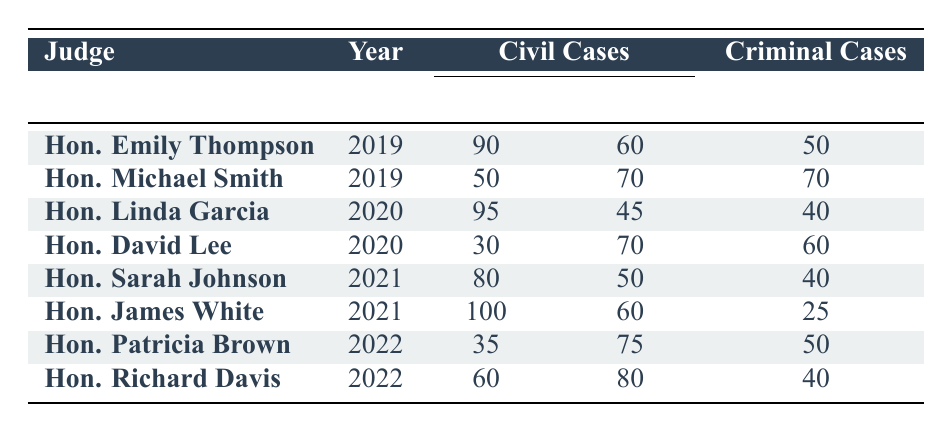What was the total number of criminal cases handled by Hon. Emily Thompson in 2019? Hon. Emily Thompson had a total of 80 criminal cases in 2019, as indicated in her row in the table under "Total Cases."
Answer: 80 How many more civil cases did Hon. David Lee handle compared to Hon. Linda Garcia in 2020? Hon. David Lee handled 100 civil cases and Hon. Linda Garcia handled 140 civil cases. The difference is 100 - 140 = -40, meaning David Lee had 40 fewer civil cases than Linda Garcia.
Answer: 40 fewer Did Hon. James White have a higher number of plaintiff wins than Hon. Sarah Johnson in 2021? Hon. James White had 100 wins for the plaintiff while Hon. Sarah Johnson had 80 wins for the plaintiff, therefore James White had a higher number of wins.
Answer: Yes What is the total number of convictions across all judges in 2022? Hon. Patricia Brown had 50 convictions and Hon. Richard Davis had 40 convictions. The total is 50 + 40 = 90 convictions.
Answer: 90 Which judge had the highest number of total civil cases in 2021? The total civil cases for Hon. Sarah Johnson is 130 and for Hon. James White is 160. Therefore, Judge James White had the highest total of civil cases in 2021.
Answer: Hon. James White What percentage of civil cases resulted in a win for the plaintiff under Hon. Michael Smith in 2019? Hon. Michael Smith had 120 total civil cases, with 50 wins for the plaintiff. The percentage is calculated as (50/120) * 100 = 41.67%.
Answer: 41.67% Who had the lowest number of win plaintiff cases in 2022? Hon. Patricia Brown had 35 win plaintiff cases, and Hon. Richard Davis had 60. Therefore, Patricia Brown had the lowest number of wins for plaintiffs in 2022.
Answer: Hon. Patricia Brown Calculate the average number of acquittals for criminal cases across all judges from 2019 to 2022. The acquittals are 30 (Emily) + 30 (Michael) + 20 (Linda) + 30 (David) + 30 (Sarah) + 30 (James) + 30 (Patricia) + 30 (Richard) = 240. There are 8 judges, so the average is 240 / 8 = 30.
Answer: 30 In 2020, which judge had a higher win ratio for defendants in civil cases: Hon. Linda Garcia or Hon. David Lee? Hon. Linda Garcia won 45 defendant cases out of 140, which gives a ratio of 45/140 = 0.321. Hon. David Lee won 70 defendant cases out of 100, which gives a ratio of 70/100 = 0.700. Thus, David Lee had a higher win ratio for defendants.
Answer: Hon. David Lee What is the difference in convictions between the judges with the highest and lowest convictions in 2022? In 2022, Hon. Patricia Brown had 50 convictions and Hon. Richard Davis had 40 convictions. The difference in convictions is 50 - 40 = 10.
Answer: 10 Did Hon. Linda Garcia have more total cases in civil or criminal categories in 2020? Hon. Linda Garcia handled 140 civil cases and 60 criminal cases in 2020. Since 140 is greater than 60, she had more total cases in civil categories.
Answer: Civil cases more 